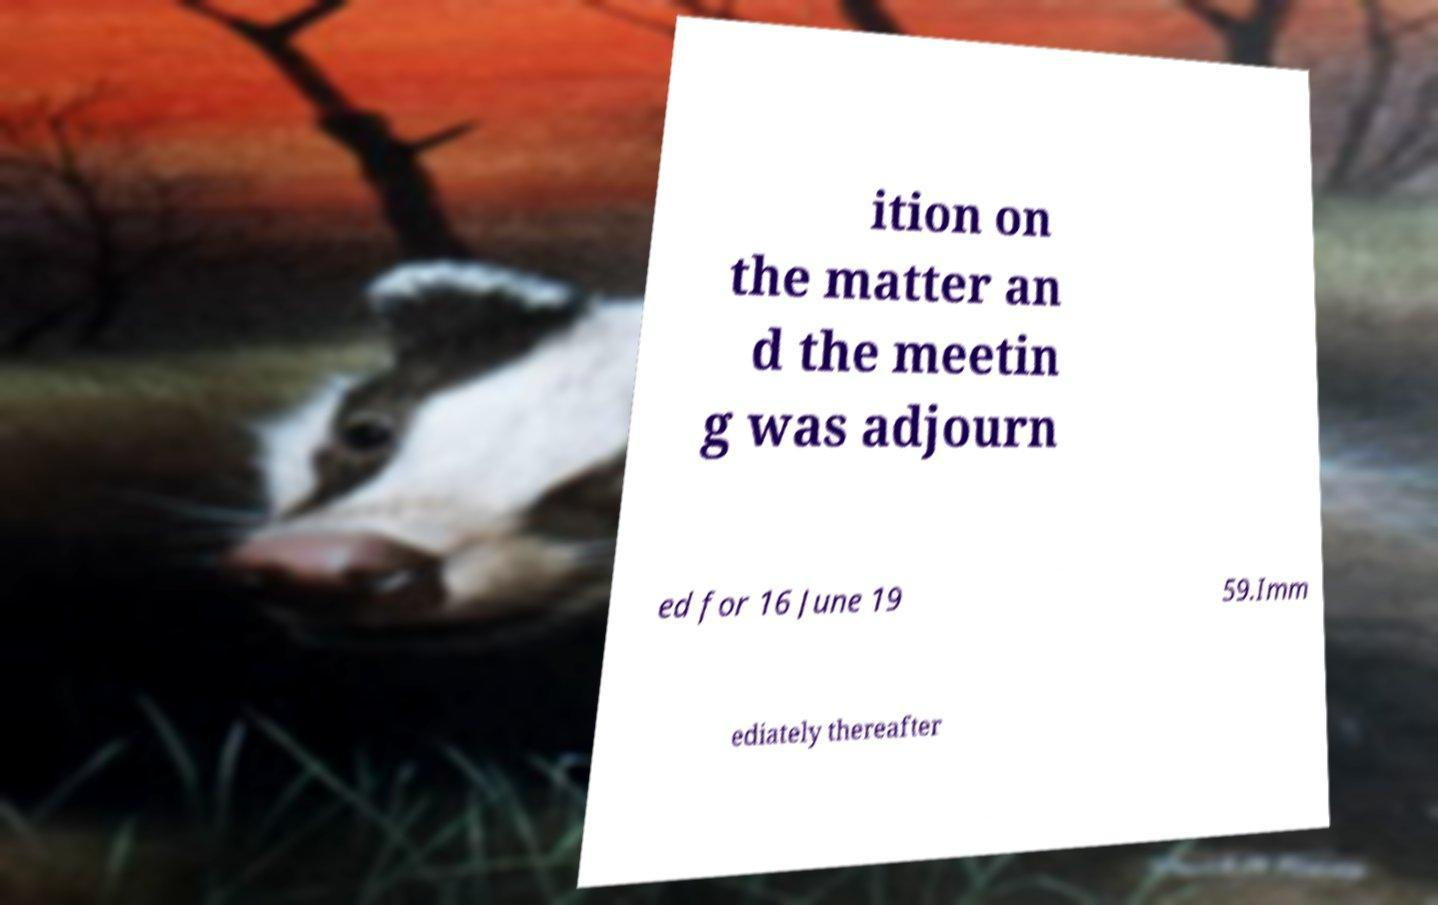Could you extract and type out the text from this image? ition on the matter an d the meetin g was adjourn ed for 16 June 19 59.Imm ediately thereafter 